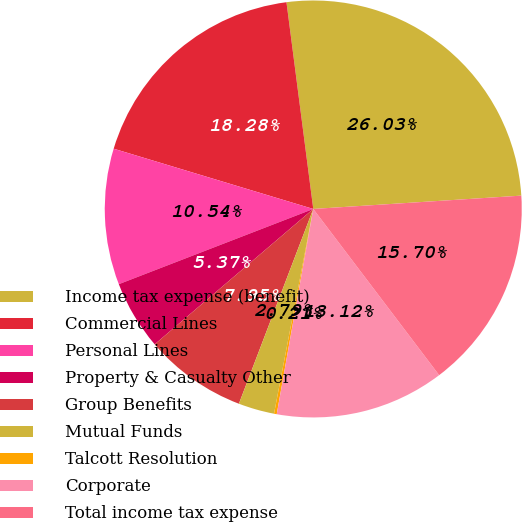Convert chart to OTSL. <chart><loc_0><loc_0><loc_500><loc_500><pie_chart><fcel>Income tax expense (benefit)<fcel>Commercial Lines<fcel>Personal Lines<fcel>Property & Casualty Other<fcel>Group Benefits<fcel>Mutual Funds<fcel>Talcott Resolution<fcel>Corporate<fcel>Total income tax expense<nl><fcel>26.03%<fcel>18.28%<fcel>10.54%<fcel>5.37%<fcel>7.95%<fcel>2.79%<fcel>0.21%<fcel>13.12%<fcel>15.7%<nl></chart> 